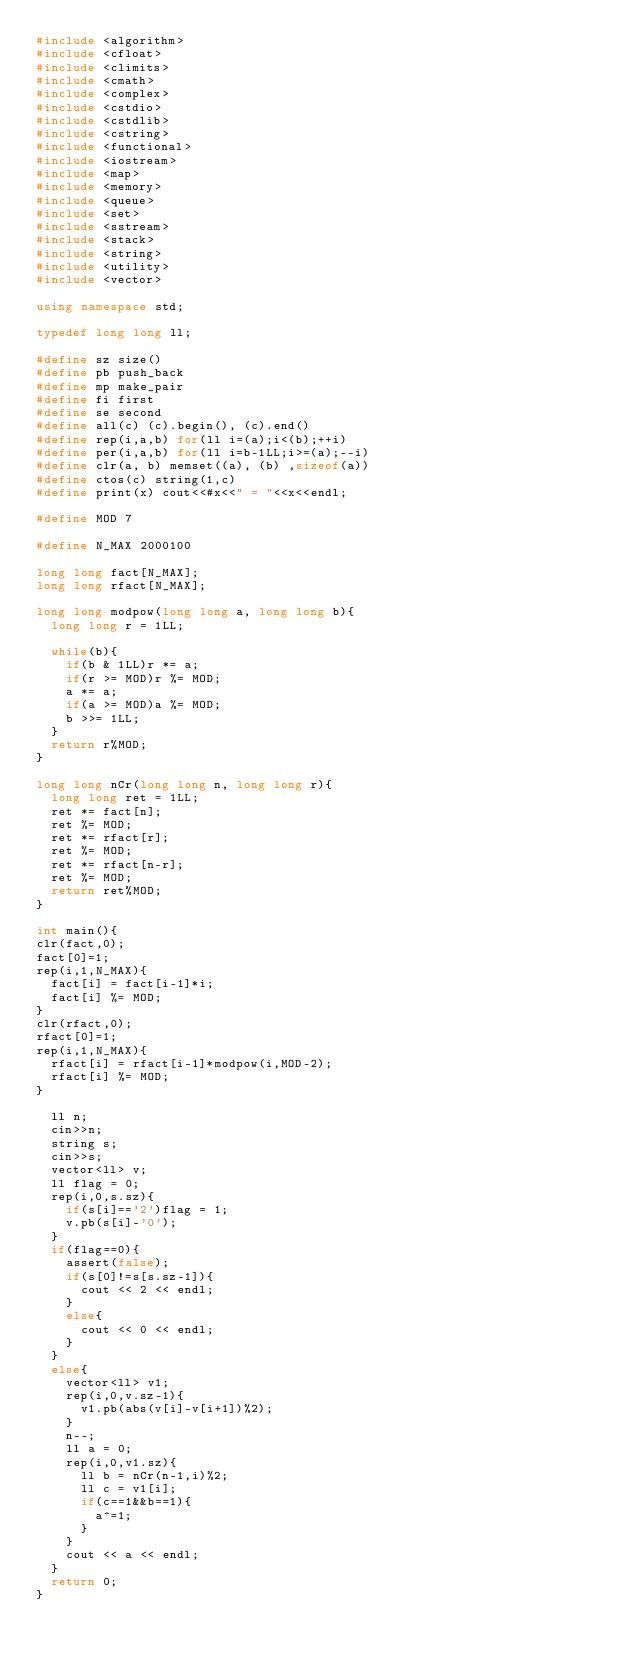Convert code to text. <code><loc_0><loc_0><loc_500><loc_500><_C++_>#include <algorithm>
#include <cfloat>
#include <climits>
#include <cmath>
#include <complex>
#include <cstdio>
#include <cstdlib>
#include <cstring>
#include <functional>
#include <iostream>
#include <map>
#include <memory>
#include <queue>
#include <set>
#include <sstream>
#include <stack>
#include <string>
#include <utility>
#include <vector>
 
using namespace std;
 
typedef long long ll;
 
#define sz size()
#define pb push_back
#define mp make_pair
#define fi first
#define se second
#define all(c) (c).begin(), (c).end()
#define rep(i,a,b) for(ll i=(a);i<(b);++i)
#define per(i,a,b) for(ll i=b-1LL;i>=(a);--i)
#define clr(a, b) memset((a), (b) ,sizeof(a))
#define ctos(c) string(1,c)
#define print(x) cout<<#x<<" = "<<x<<endl;
 
#define MOD 7

#define N_MAX 2000100

long long fact[N_MAX];
long long rfact[N_MAX];

long long modpow(long long a, long long b){ 
  long long r = 1LL;

  while(b){
    if(b & 1LL)r *= a;
    if(r >= MOD)r %= MOD;
    a *= a;
    if(a >= MOD)a %= MOD;
    b >>= 1LL;
  }
  return r%MOD;
}

long long nCr(long long n, long long r){ 
  long long ret = 1LL;
  ret *= fact[n];
  ret %= MOD;
  ret *= rfact[r];
  ret %= MOD;
  ret *= rfact[n-r];
  ret %= MOD;
  return ret%MOD;
}

int main(){
clr(fact,0);
fact[0]=1;
rep(i,1,N_MAX){
  fact[i] = fact[i-1]*i;
  fact[i] %= MOD;
}
clr(rfact,0);
rfact[0]=1;
rep(i,1,N_MAX){
  rfact[i] = rfact[i-1]*modpow(i,MOD-2);
  rfact[i] %= MOD;
}

  ll n;
  cin>>n;
  string s;
  cin>>s;
  vector<ll> v;
  ll flag = 0;
  rep(i,0,s.sz){
    if(s[i]=='2')flag = 1;
    v.pb(s[i]-'0');
  }
  if(flag==0){
    assert(false);
    if(s[0]!=s[s.sz-1]){
      cout << 2 << endl;
    }
    else{
      cout << 0 << endl;
    }
  }
  else{
    vector<ll> v1;
    rep(i,0,v.sz-1){
      v1.pb(abs(v[i]-v[i+1])%2);
    }
    n--;
    ll a = 0;
    rep(i,0,v1.sz){
      ll b = nCr(n-1,i)%2;
      ll c = v1[i];
      if(c==1&&b==1){
        a^=1;
      }
    }
    cout << a << endl;
  }
  return 0;
}</code> 